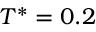<formula> <loc_0><loc_0><loc_500><loc_500>T ^ { * } = 0 . 2</formula> 